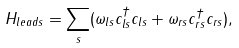Convert formula to latex. <formula><loc_0><loc_0><loc_500><loc_500>H _ { l e a d s } = \sum _ { s } ( \omega _ { l s } c _ { l s } ^ { \dag } c _ { l s } + \omega _ { r s } c _ { r s } ^ { \dag } c _ { r s } ) ,</formula> 